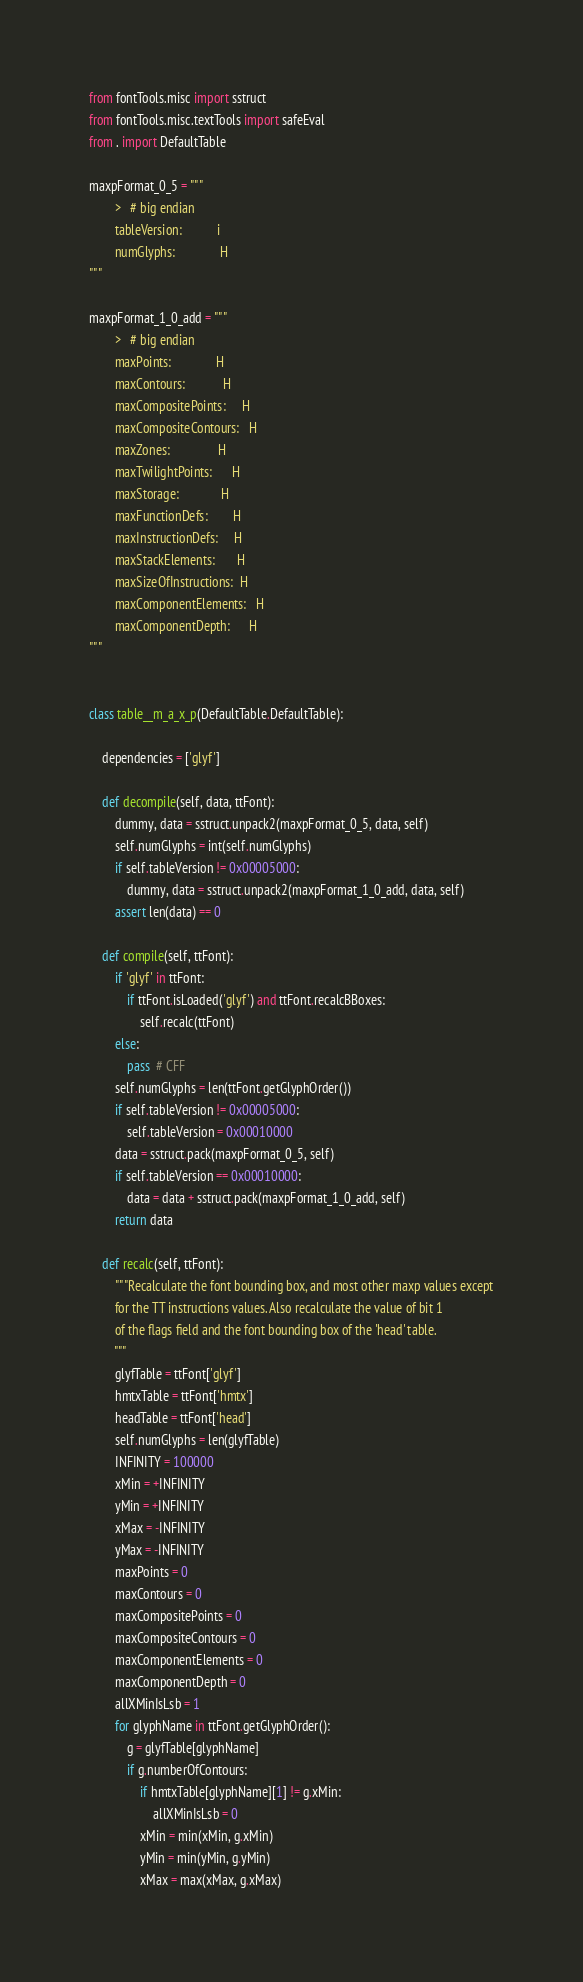Convert code to text. <code><loc_0><loc_0><loc_500><loc_500><_Python_>from fontTools.misc import sstruct
from fontTools.misc.textTools import safeEval
from . import DefaultTable

maxpFormat_0_5 = """
		>	# big endian
		tableVersion:           i
		numGlyphs:              H
"""

maxpFormat_1_0_add = """
		>	# big endian
		maxPoints:              H
		maxContours:            H
		maxCompositePoints:     H
		maxCompositeContours:   H
		maxZones:               H
		maxTwilightPoints:      H
		maxStorage:             H
		maxFunctionDefs:        H
		maxInstructionDefs:     H
		maxStackElements:       H
		maxSizeOfInstructions:  H
		maxComponentElements:   H
		maxComponentDepth:      H
"""


class table__m_a_x_p(DefaultTable.DefaultTable):

	dependencies = ['glyf']

	def decompile(self, data, ttFont):
		dummy, data = sstruct.unpack2(maxpFormat_0_5, data, self)
		self.numGlyphs = int(self.numGlyphs)
		if self.tableVersion != 0x00005000:
			dummy, data = sstruct.unpack2(maxpFormat_1_0_add, data, self)
		assert len(data) == 0

	def compile(self, ttFont):
		if 'glyf' in ttFont:
			if ttFont.isLoaded('glyf') and ttFont.recalcBBoxes:
				self.recalc(ttFont)
		else:
			pass  # CFF
		self.numGlyphs = len(ttFont.getGlyphOrder())
		if self.tableVersion != 0x00005000:
			self.tableVersion = 0x00010000
		data = sstruct.pack(maxpFormat_0_5, self)
		if self.tableVersion == 0x00010000:
			data = data + sstruct.pack(maxpFormat_1_0_add, self)
		return data

	def recalc(self, ttFont):
		"""Recalculate the font bounding box, and most other maxp values except
		for the TT instructions values. Also recalculate the value of bit 1
		of the flags field and the font bounding box of the 'head' table.
		"""
		glyfTable = ttFont['glyf']
		hmtxTable = ttFont['hmtx']
		headTable = ttFont['head']
		self.numGlyphs = len(glyfTable)
		INFINITY = 100000
		xMin = +INFINITY
		yMin = +INFINITY
		xMax = -INFINITY
		yMax = -INFINITY
		maxPoints = 0
		maxContours = 0
		maxCompositePoints = 0
		maxCompositeContours = 0
		maxComponentElements = 0
		maxComponentDepth = 0
		allXMinIsLsb = 1
		for glyphName in ttFont.getGlyphOrder():
			g = glyfTable[glyphName]
			if g.numberOfContours:
				if hmtxTable[glyphName][1] != g.xMin:
					allXMinIsLsb = 0
				xMin = min(xMin, g.xMin)
				yMin = min(yMin, g.yMin)
				xMax = max(xMax, g.xMax)</code> 